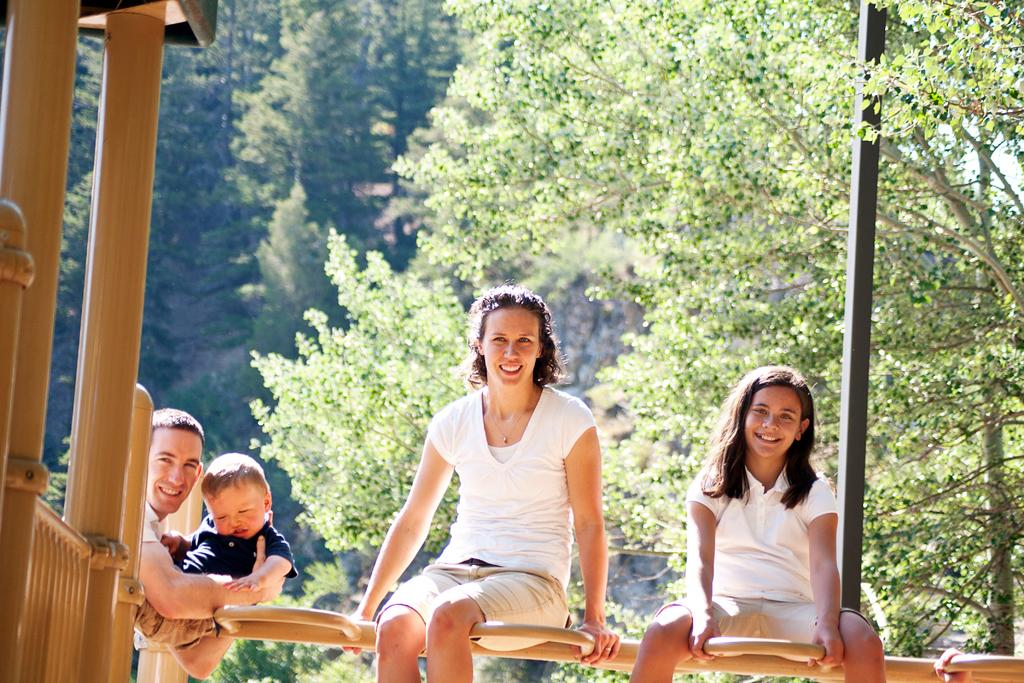How many people are in the image? There are people in the image, but the exact number is not specified. What are the two people sitting on? The two people are sitting on a wooden surface. What type of structures can be seen in the image? There are wooden pillars, a fence, and a pole in the image. What type of natural elements are present in the image? Trees are present in the image, and the sky is visible. How long does it take for the mother to reach the brake in the image? There is no mother or brake present in the image. 